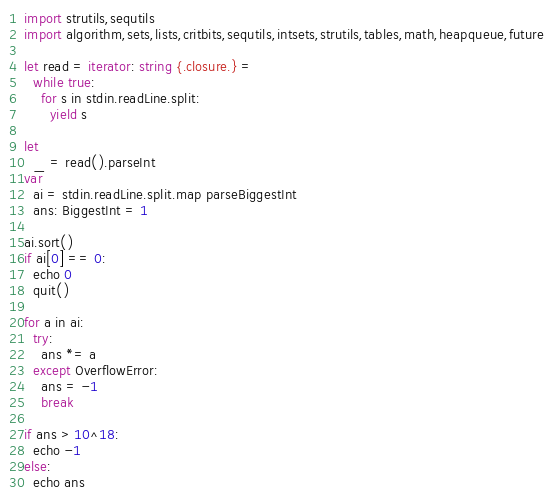Convert code to text. <code><loc_0><loc_0><loc_500><loc_500><_Nim_>import strutils,sequtils
import algorithm,sets,lists,critbits,sequtils,intsets,strutils,tables,math,heapqueue,future

let read = iterator: string {.closure.} =
  while true:
    for s in stdin.readLine.split:
      yield s

let
  _ = read().parseInt
var
  ai = stdin.readLine.split.map parseBiggestInt
  ans: BiggestInt = 1

ai.sort()
if ai[0] == 0:
  echo 0
  quit()

for a in ai:
  try:
    ans *= a
  except OverflowError:
    ans = -1
    break

if ans > 10^18:
  echo -1
else:
  echo ans
</code> 